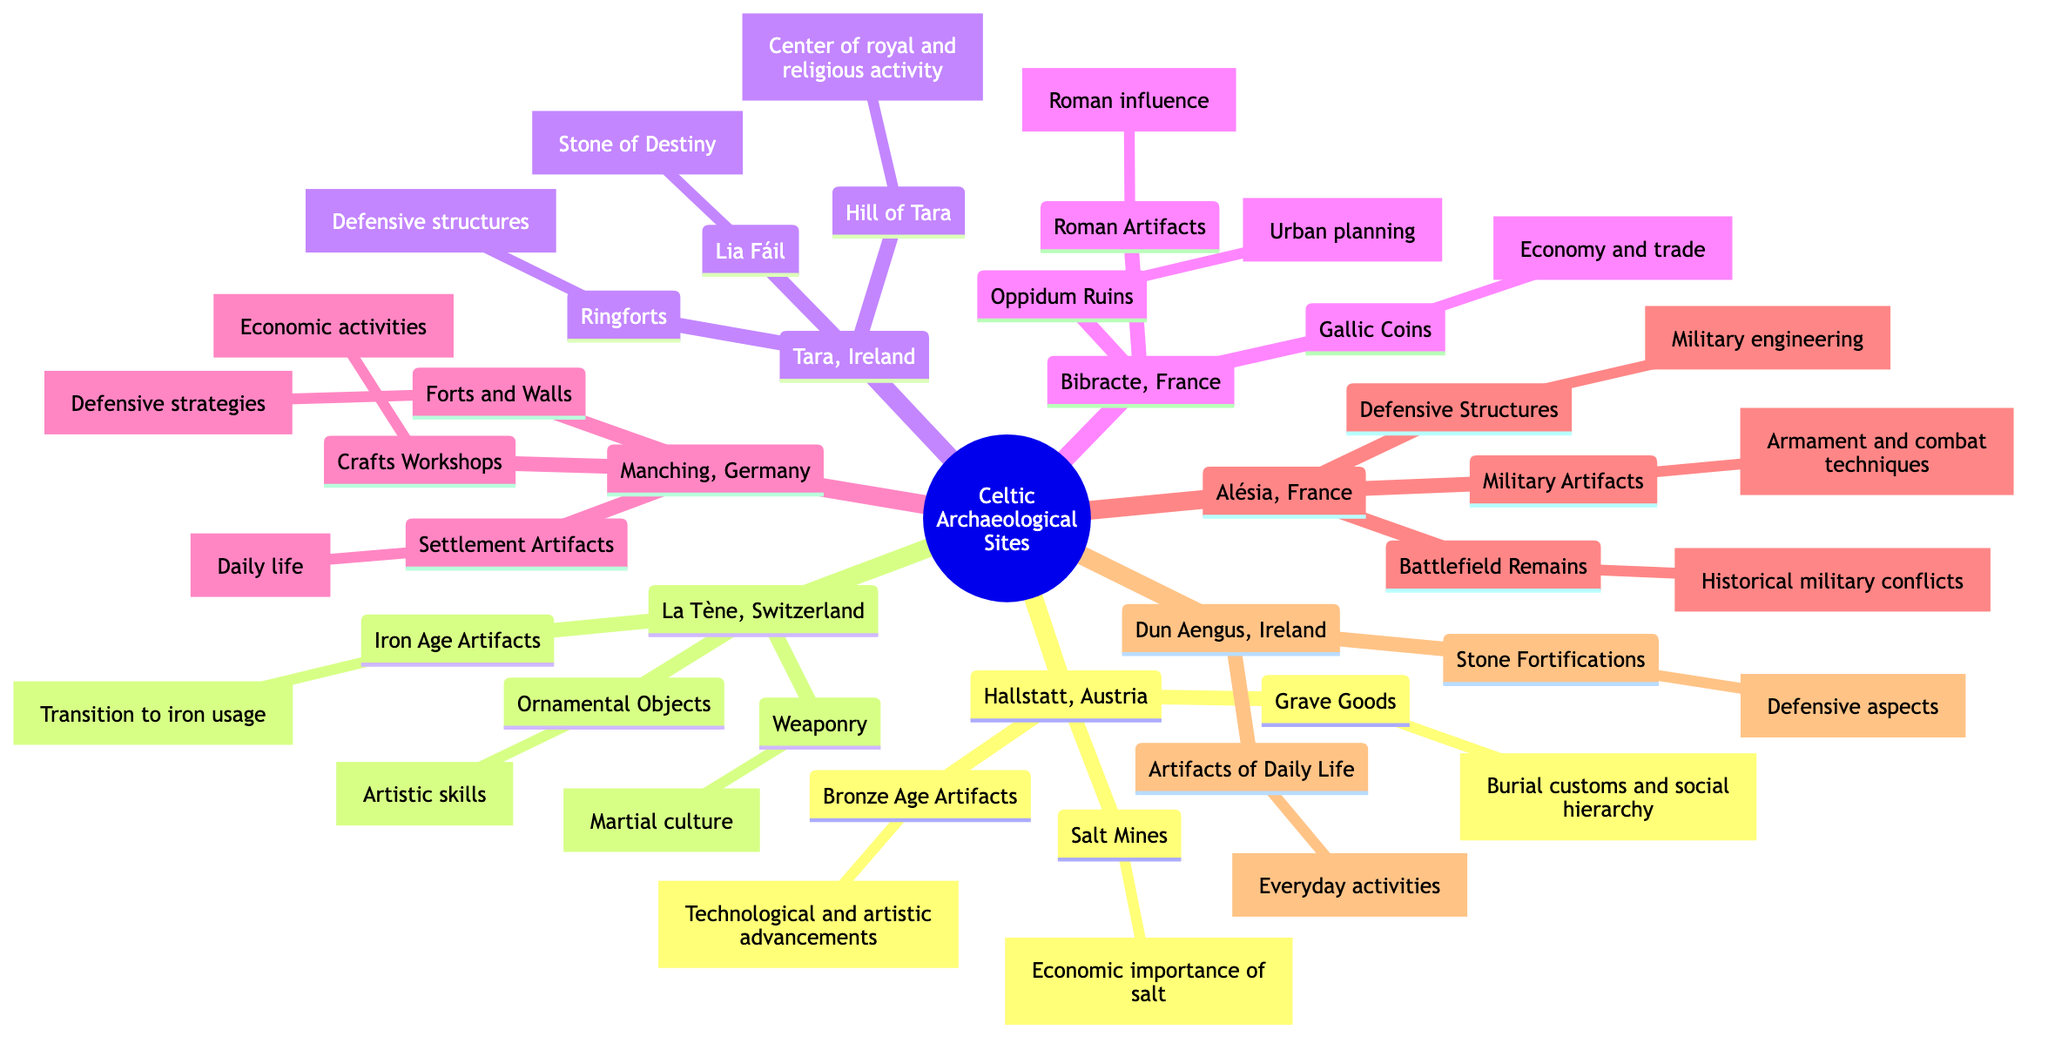What is the type site for the Hallstatt culture? The diagram identifies "Hallstatt, Austria" as the type site for the Hallstatt culture. This is derived directly from the root labeled "Key Archaeological Sites".
Answer: Hallstatt, Austria How many discoveries are listed for La Tène, Switzerland? By counting the nodes under "La Tène, Switzerland", we see "Iron Age Artifacts", "Ornamental Objects", and "Weaponry", totaling three discoveries.
Answer: 3 Which site contains the Lia Fáil? The diagram shows "Lia Fáil" listed under "Tara, Ireland", indicating that it is that site's significant artifact.
Answer: Tara, Ireland What discovery indicates the economic importance of salt? The diagram connects "Salt Mines" to "Hallstatt, Austria", and states that it indicates the economic importance of salt in that region.
Answer: Salt Mines What do the artifacts from Manching, Germany represent about daily life? The node "Settlement Artifacts" under "Manching, Germany" suggests that they represent aspects of daily life in ancient Celtic settlements.
Answer: Settlement Artifacts What do the Defensive Structures at Alésia illustrate? The diagram states that "Defensive Structures" illustrate military engineering, as shown in the contextual description fixed to that node in the diagram.
Answer: Military engineering How many key archaeological sites are listed in the diagram? By counting, we find that there are seven key archaeological sites: Hallstatt, La Tène, Tara, Bibracte, Manching, Alésia, and Dun Aengus.
Answer: 7 Which site provides evidence of urban planning? "Oppidum Ruins" is associated with "Bibracte, France", indicating that it provides evidence of urban planning within that context.
Answer: Bibracte, France What do Battlefield Remains at Alésia provide evidence of? The diagram connects "Battlefield Remains" to "Alésia, France", indicating that they provide evidence of significant historical military conflicts.
Answer: Military conflicts 